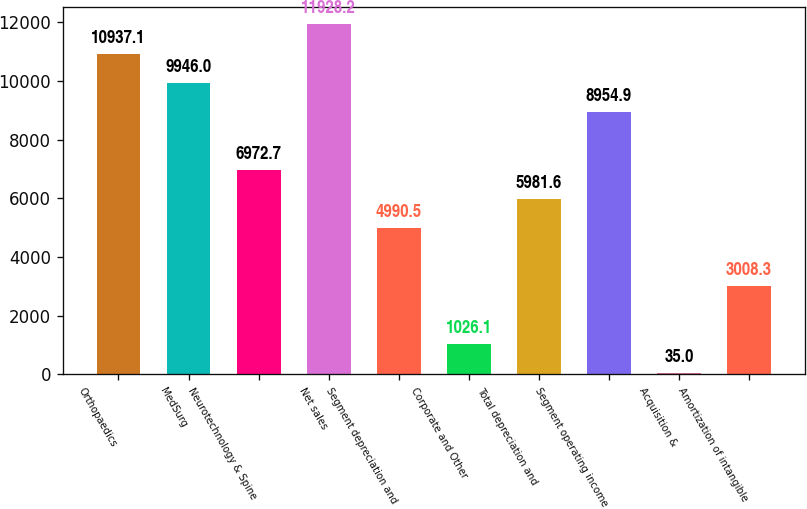<chart> <loc_0><loc_0><loc_500><loc_500><bar_chart><fcel>Orthopaedics<fcel>MedSurg<fcel>Neurotechnology & Spine<fcel>Net sales<fcel>Segment depreciation and<fcel>Corporate and Other<fcel>Total depreciation and<fcel>Segment operating income<fcel>Acquisition &<fcel>Amortization of intangible<nl><fcel>10937.1<fcel>9946<fcel>6972.7<fcel>11928.2<fcel>4990.5<fcel>1026.1<fcel>5981.6<fcel>8954.9<fcel>35<fcel>3008.3<nl></chart> 